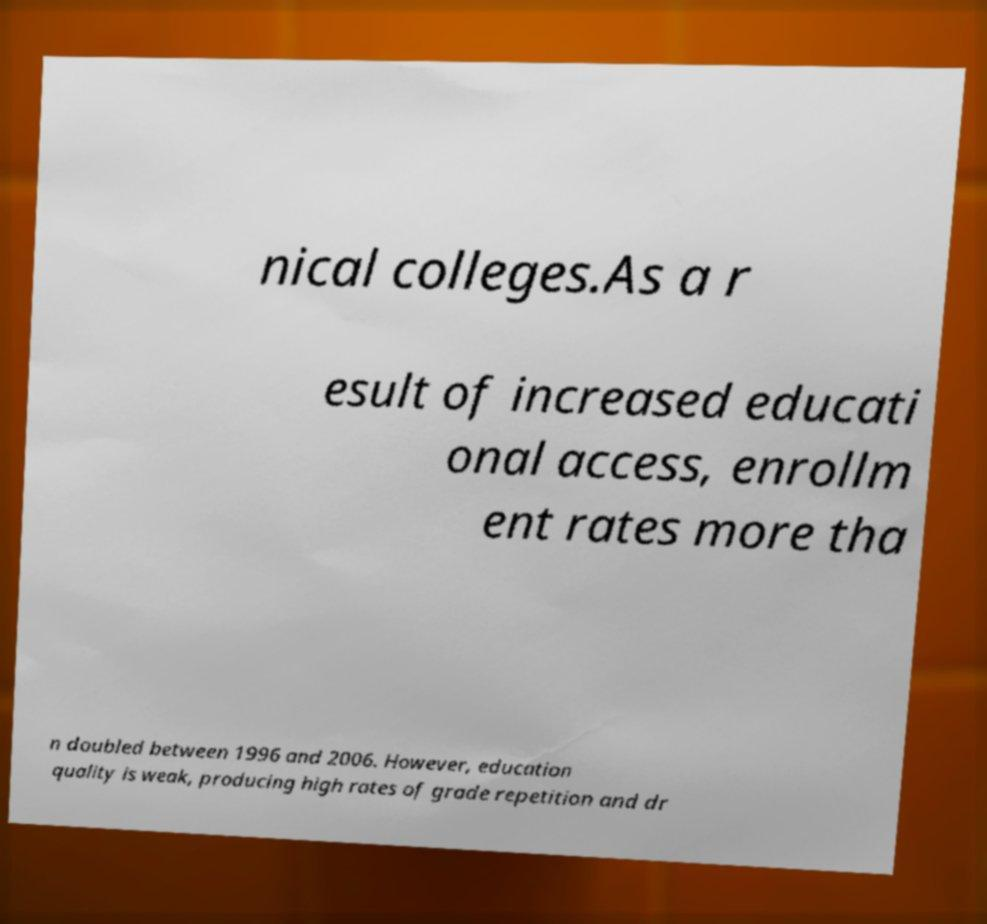Please identify and transcribe the text found in this image. nical colleges.As a r esult of increased educati onal access, enrollm ent rates more tha n doubled between 1996 and 2006. However, education quality is weak, producing high rates of grade repetition and dr 